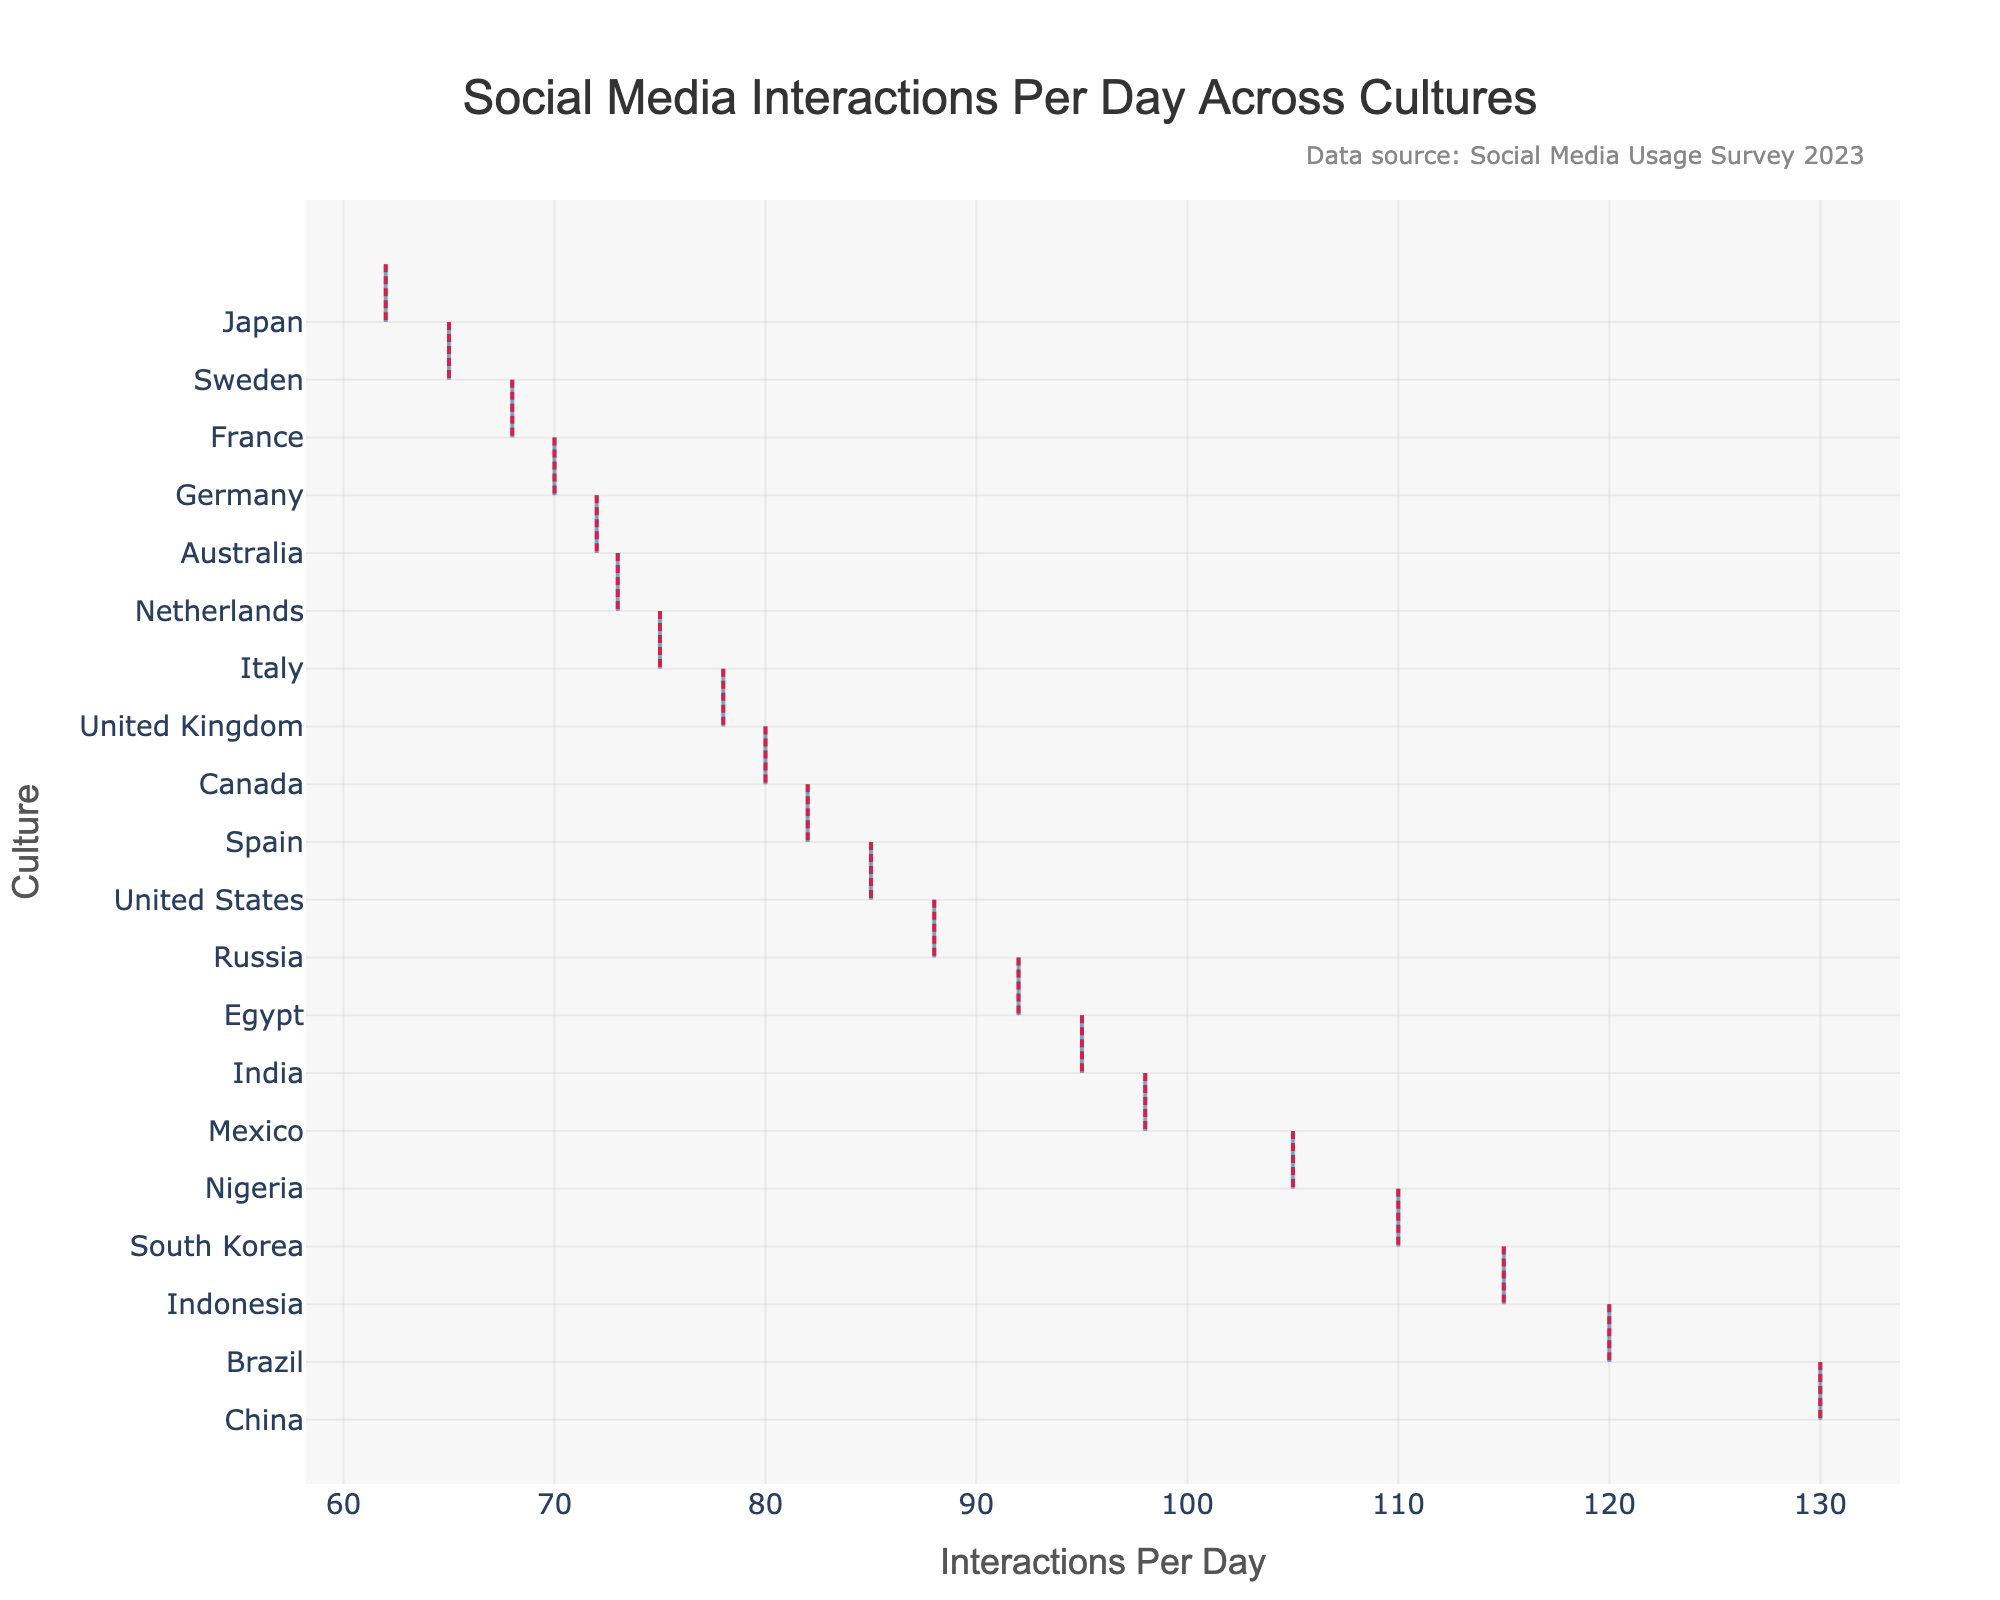What is the title of the plot? The title is located at the top of the plot and reads, "Social Media Interactions Per Day Across Cultures".
Answer: Social Media Interactions Per Day Across Cultures What is the range of social media interactions per day shown in the plot? The range can be determined by looking at the x-axis, which shows interactions from the lowest value of 62 (Japan) to the highest value of 130 (China).
Answer: 62 to 130 Which culture has the highest number of social media interactions per day? The highest interaction value is at the top of the plot, corresponding to China with 130 interactions per day.
Answer: China What is the mean line color used in the plot? The mean line is visible as a line across the distribution and is colored in a vibrant red hue.
Answer: Red Which cultures have more than 100 interactions per day? By checking the x-axis values and corresponding cultures, the ones with more than 100 interactions per day are Brazil, South Korea, China, Nigeria, and Indonesia.
Answer: Brazil, South Korea, China, Nigeria, Indonesia What is the average number of daily interactions for cultures with less than 80 interactions per day? Cultures with interactions per day less than 80 are Japan (62), Germany (70), France (68), Sweden (65), and Italy (75). The average is calculated as (62 + 70 + 68 + 65 + 75) / 5 = 68.
Answer: 68 Which cultures have interactions per day closest to the mean value, and what is that value? The mean line helps indicate the average value, and cultures closest to it are compared by proximity. The approximate interactions per day range around the mean of the displayed cultures.
Answer: Italy, United Kingdom, Spain (with mean around 79-82) How does the interaction frequency of India compare to Brazil's? India has 95 interactions per day, while Brazil has 120. Brazil has significantly more interactions compared to India.
Answer: Brazil has more Which culture(s) have the lowest social media interactions per day and what is the interaction value? The lowest interaction values are located at the bottom of the plot, with Japan having the lowest at 62.
Answer: Japan with 62 How is the plot visually divided to show data distribution for each culture? The plot uses a horizontal violin plot where each culture's distribution of interactions is shown as a widening or narrowing shape perpendicular to the x-axis representing interaction frequency.
Answer: Violin-shape distributions 